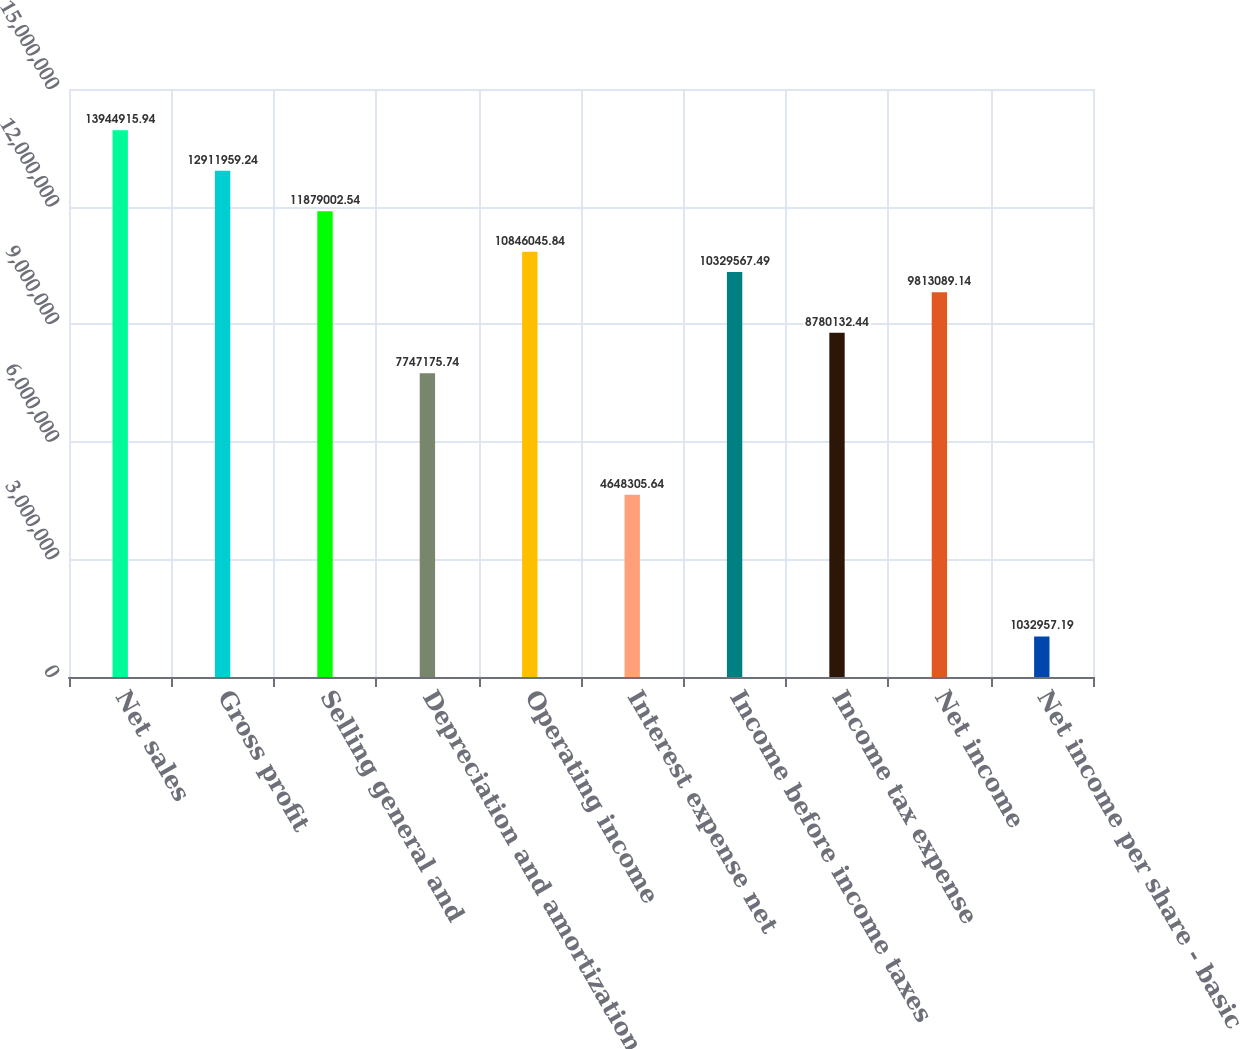<chart> <loc_0><loc_0><loc_500><loc_500><bar_chart><fcel>Net sales<fcel>Gross profit<fcel>Selling general and<fcel>Depreciation and amortization<fcel>Operating income<fcel>Interest expense net<fcel>Income before income taxes<fcel>Income tax expense<fcel>Net income<fcel>Net income per share - basic<nl><fcel>1.39449e+07<fcel>1.2912e+07<fcel>1.1879e+07<fcel>7.74718e+06<fcel>1.0846e+07<fcel>4.64831e+06<fcel>1.03296e+07<fcel>8.78013e+06<fcel>9.81309e+06<fcel>1.03296e+06<nl></chart> 